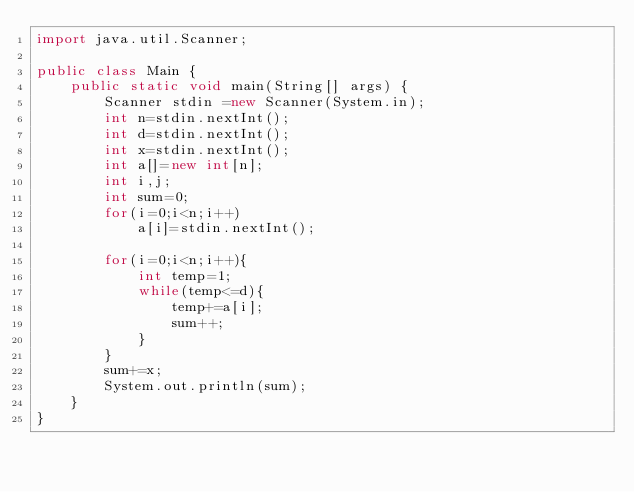<code> <loc_0><loc_0><loc_500><loc_500><_Java_>import java.util.Scanner;

public class Main {
	public static void main(String[] args) {
		Scanner stdin =new Scanner(System.in);
		int n=stdin.nextInt();
		int d=stdin.nextInt();
		int x=stdin.nextInt();
		int a[]=new int[n];
		int i,j;
		int sum=0;
		for(i=0;i<n;i++)
			a[i]=stdin.nextInt();

		for(i=0;i<n;i++){
			int temp=1;
			while(temp<=d){
				temp+=a[i];
				sum++;
			}
		}
		sum+=x;
		System.out.println(sum);
	}
}</code> 